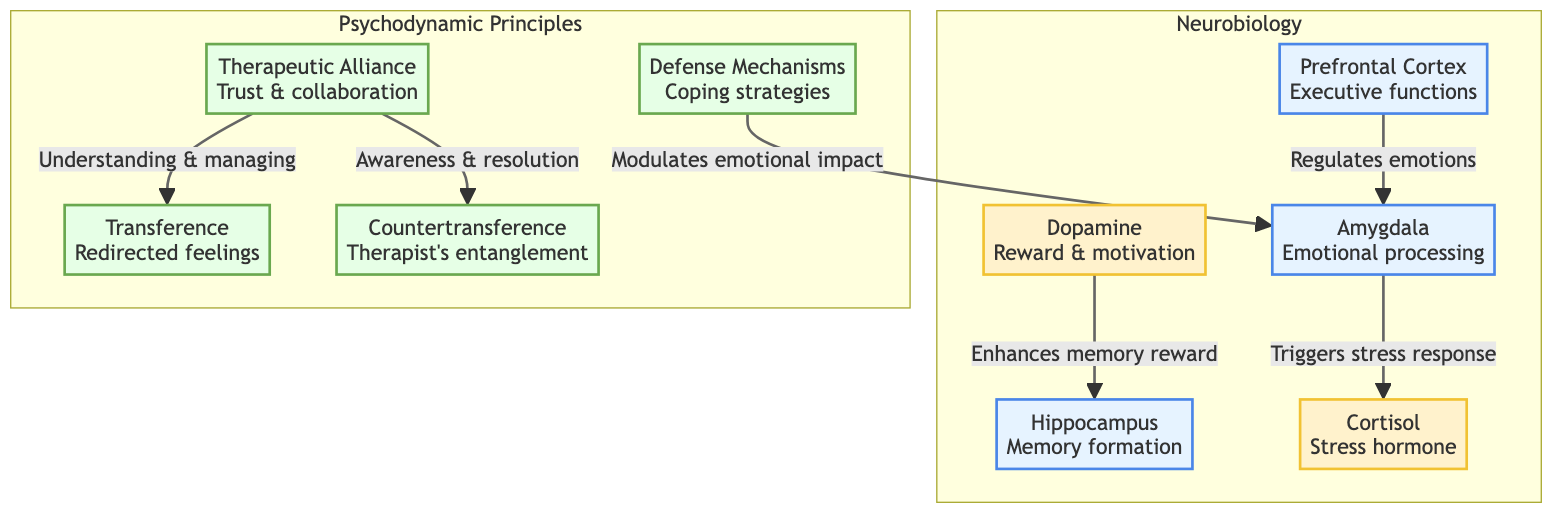What brain structure is responsible for executive functions? The diagram indicates that the prefrontal cortex is associated with executive functions. It is specifically labeled as such within the diagram.
Answer: Prefrontal Cortex Which neurotransmitter is linked to reward and motivation? The diagram shows that dopamine is the neurotransmitter associated with reward and motivation, as indicated by its labeled description.
Answer: Dopamine How many brain structures are illustrated in the diagram? By counting the nodes within the "Neurobiology" subgraph, we identify four brain structures: prefrontal cortex, amygdala, hippocampus, and dopamine, but dopamine is a neurotransmitter. Therefore, there are three brain structures.
Answer: 3 What effect does cortisol have according to the diagram? The relationship in the diagram indicates that the amygdala triggers the stress response and that cortisol is the hormone involved in this response. This shows its direct effect: triggering the stress response.
Answer: Triggers stress response Which psychodynamic principle is associated with understanding and managing transference? The diagram indicates that the therapeutic alliance facilitates the understanding and managing of transference. This relationship is reflected in the flow connecting therapeutic alliance to transference.
Answer: Therapeutic Alliance What role does dopamine play in relation to memory? According to the diagram, dopamine enhances memory reward, showing its significant role in the memory process, especially as it relates to the hippocampus.
Answer: Enhances memory reward How does therapeutic alliance relate to countertransference? The diagram shows that the therapeutic alliance contributes to awareness and resolution of countertransference, indicating a significant relational dynamic within the therapy context.
Answer: Awareness & resolution What is the primary coping strategy listed in the diagram? The diagram identifies defense mechanisms as the primary coping strategy within the psychodynamic principles section, relating it to emotional impact modulation.
Answer: Defense Mechanisms What triggers emotional processing in the brain? The diagram indicates that the amygdala is responsible for emotional processing and that it is influenced by prefrontal cortex activity that regulates emotions.
Answer: Amygdala 